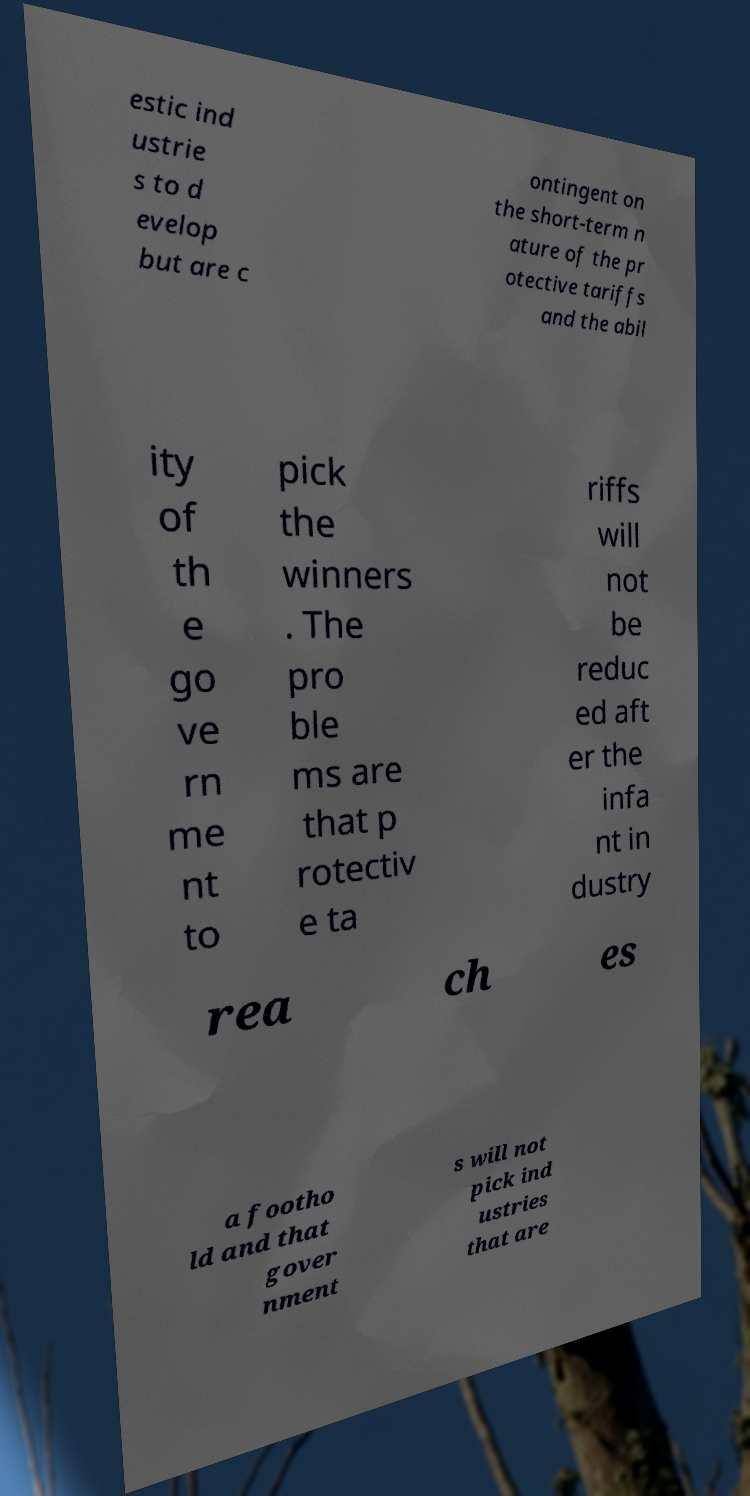For documentation purposes, I need the text within this image transcribed. Could you provide that? estic ind ustrie s to d evelop but are c ontingent on the short-term n ature of the pr otective tariffs and the abil ity of th e go ve rn me nt to pick the winners . The pro ble ms are that p rotectiv e ta riffs will not be reduc ed aft er the infa nt in dustry rea ch es a footho ld and that gover nment s will not pick ind ustries that are 